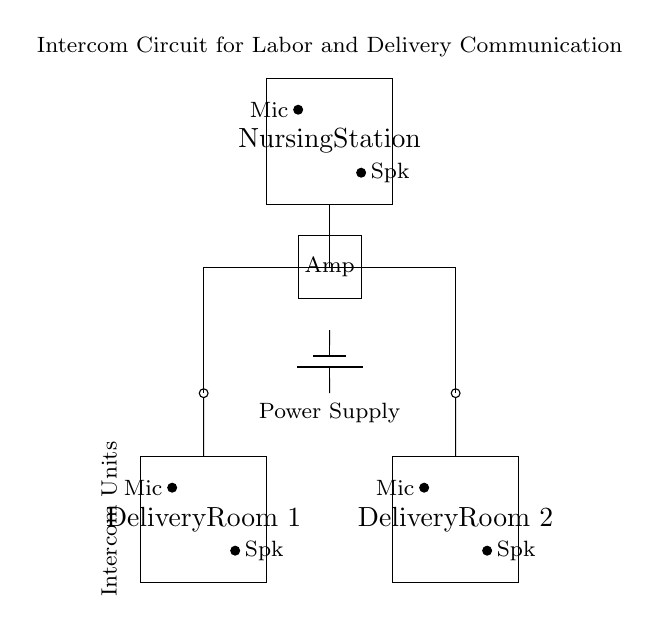What are the components used in this intercom circuit? The circuit includes two microphones, two speakers, an amplifier, and a power supply. These components are essential for allowing sound communication between the delivery rooms and the nursing station.
Answer: microphones, speakers, amplifier, power supply How many delivery rooms are connected in this circuit? There are two delivery rooms represented in the circuit diagram, each having its own microphone and speaker setup for communication.
Answer: two What is the role of the amplifier in this circuit? The amplifier’s role is to strengthen the audio signals received from the microphones before sending them to the speakers, ensuring clear communication.
Answer: strengthen audio signals Where is the power supply located in the circuit? The power supply is located between the amplifier and the circuit lines that connect to the delivery rooms, indicating it provides the necessary voltage for the intercom system.
Answer: between the amplifier and the circuit lines Which component is used for receiving sound in the delivery rooms? The microphones are used for receiving sound in the delivery rooms, allowing the staff to communicate with the nursing station effectively.
Answer: microphones How do the microphones and speakers connect to the intercom system? The microphones are connected to their respective speakers through a direct line that leads to the amplifier and ultimately to the nursing station, allowing bidirectional communication.
Answer: through direct connections to the amplifier What is the purpose of using an intercom system in a labor and delivery setting? The intercom system facilitates immediate and effective communication between delivery rooms and nursing stations, essential for patient care during labor.
Answer: immediate communication 